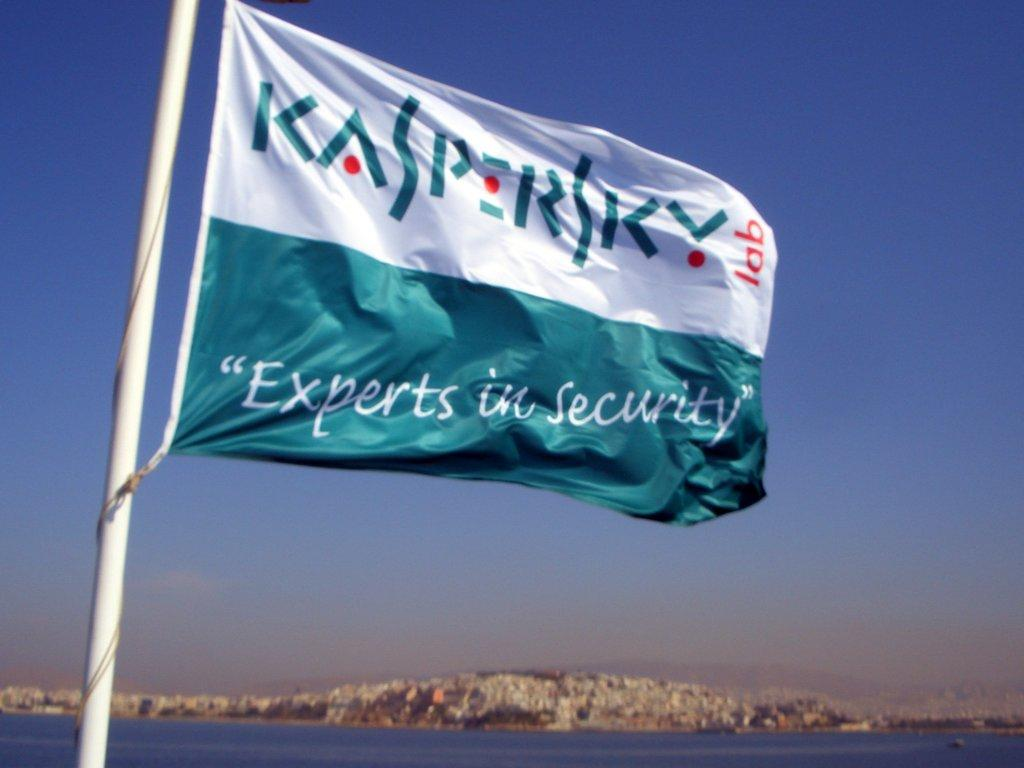What is the main object in the image? There is a flag in the image. What is located at the bottom of the image? There is water at the bottom of the image. What can be seen in the background of the image? There is a mountain visible in the background of the image. What is visible at the top of the image? The sky is visible at the top of the image. How many units are present at the party in the image? There is no party or unit present in the image; it features a flag, water, a mountain, and the sky. 